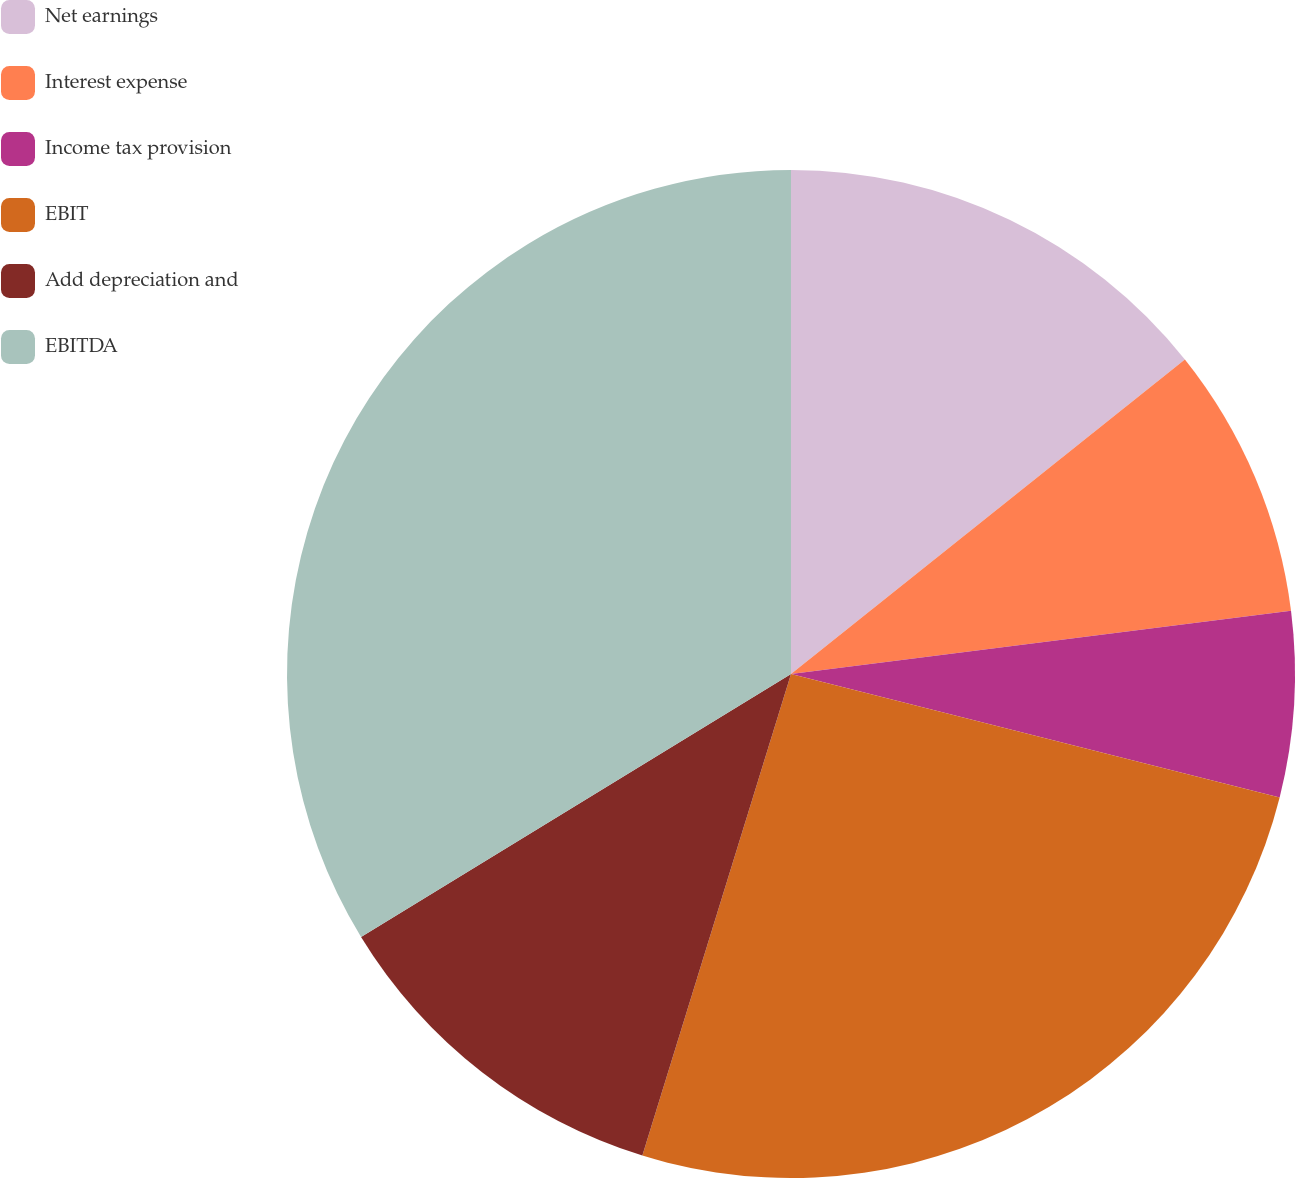Convert chart. <chart><loc_0><loc_0><loc_500><loc_500><pie_chart><fcel>Net earnings<fcel>Interest expense<fcel>Income tax provision<fcel>EBIT<fcel>Add depreciation and<fcel>EBITDA<nl><fcel>14.28%<fcel>8.72%<fcel>5.94%<fcel>25.83%<fcel>11.5%<fcel>33.74%<nl></chart> 